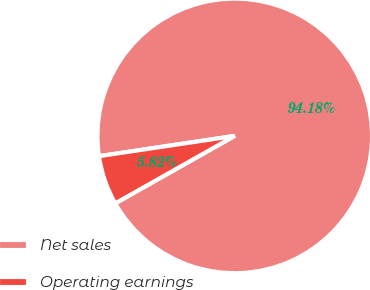Convert chart to OTSL. <chart><loc_0><loc_0><loc_500><loc_500><pie_chart><fcel>Net sales<fcel>Operating earnings<nl><fcel>94.18%<fcel>5.82%<nl></chart> 